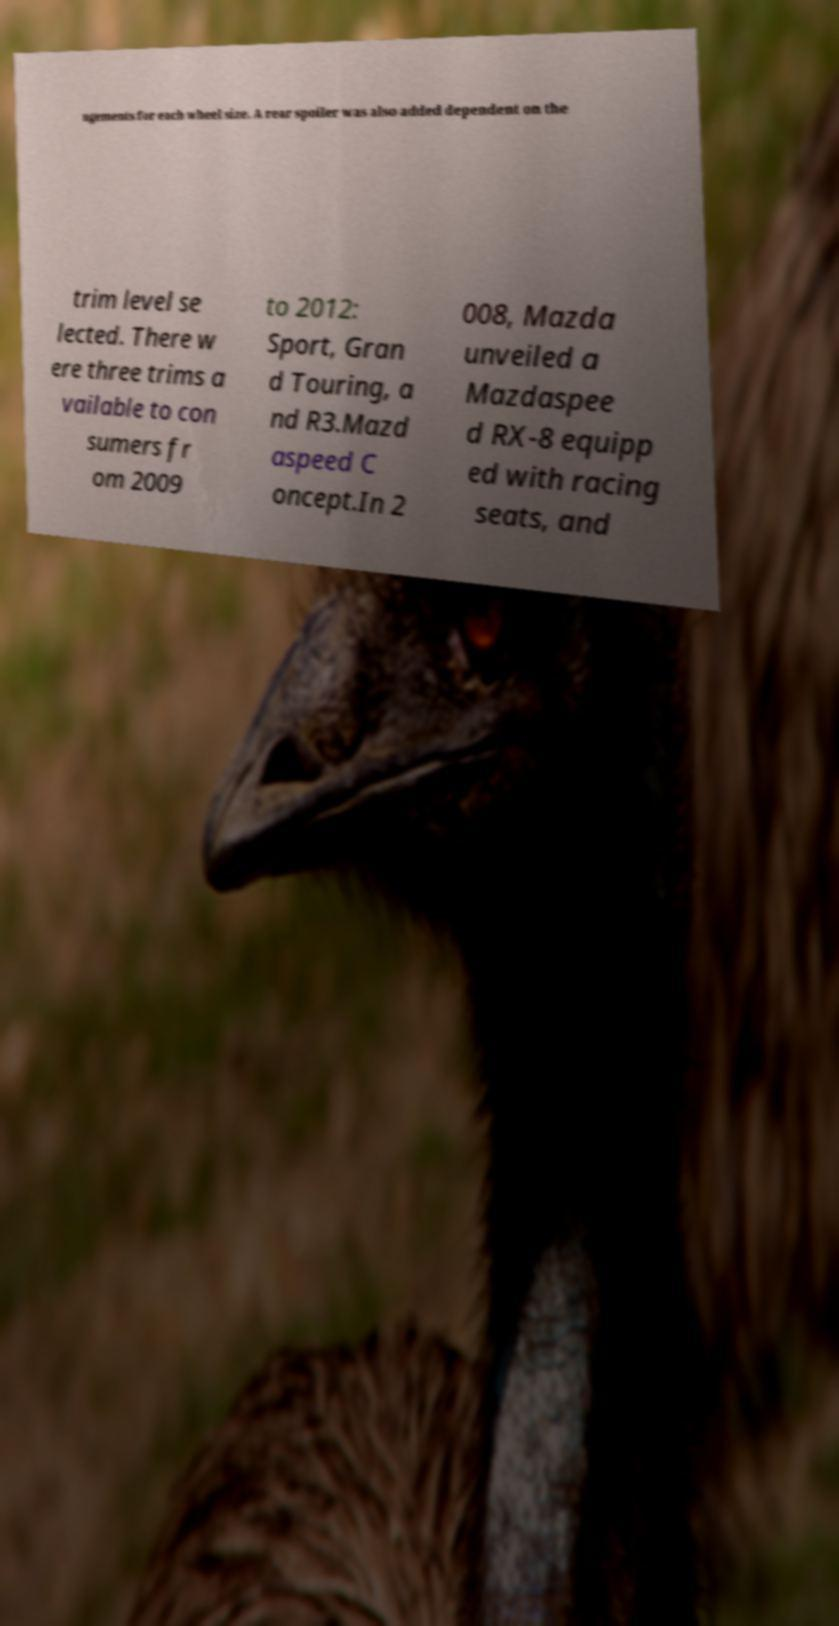I need the written content from this picture converted into text. Can you do that? ngements for each wheel size. A rear spoiler was also added dependent on the trim level se lected. There w ere three trims a vailable to con sumers fr om 2009 to 2012: Sport, Gran d Touring, a nd R3.Mazd aspeed C oncept.In 2 008, Mazda unveiled a Mazdaspee d RX-8 equipp ed with racing seats, and 